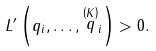<formula> <loc_0><loc_0><loc_500><loc_500>L ^ { \prime } \left ( q _ { i } , \dots , \stackrel { \left ( K \right ) } { q } _ { i } \right ) > 0 .</formula> 